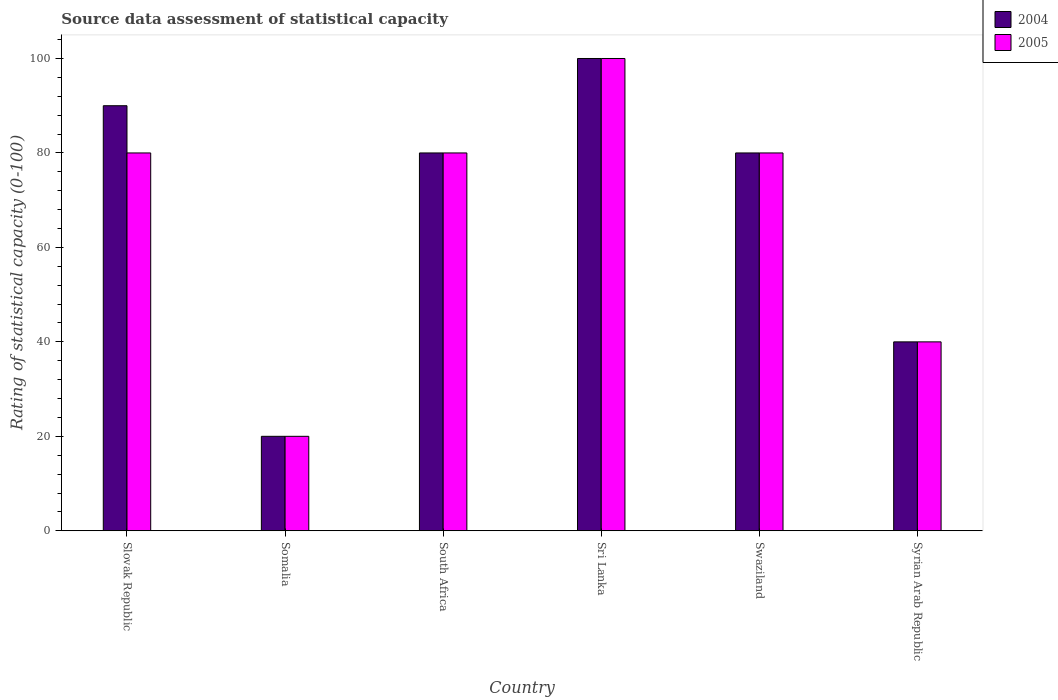How many different coloured bars are there?
Provide a succinct answer. 2. How many groups of bars are there?
Offer a terse response. 6. How many bars are there on the 1st tick from the left?
Provide a succinct answer. 2. What is the label of the 1st group of bars from the left?
Make the answer very short. Slovak Republic. What is the rating of statistical capacity in 2004 in Swaziland?
Offer a terse response. 80. Across all countries, what is the minimum rating of statistical capacity in 2004?
Ensure brevity in your answer.  20. In which country was the rating of statistical capacity in 2005 maximum?
Offer a terse response. Sri Lanka. In which country was the rating of statistical capacity in 2005 minimum?
Ensure brevity in your answer.  Somalia. What is the total rating of statistical capacity in 2004 in the graph?
Your answer should be compact. 410. What is the average rating of statistical capacity in 2004 per country?
Your answer should be very brief. 68.33. In how many countries, is the rating of statistical capacity in 2005 greater than 76?
Offer a terse response. 4. What is the ratio of the rating of statistical capacity in 2005 in Slovak Republic to that in Swaziland?
Keep it short and to the point. 1. Is the difference between the rating of statistical capacity in 2005 in Somalia and Swaziland greater than the difference between the rating of statistical capacity in 2004 in Somalia and Swaziland?
Ensure brevity in your answer.  No. In how many countries, is the rating of statistical capacity in 2005 greater than the average rating of statistical capacity in 2005 taken over all countries?
Offer a terse response. 4. Is the sum of the rating of statistical capacity in 2004 in Swaziland and Syrian Arab Republic greater than the maximum rating of statistical capacity in 2005 across all countries?
Your answer should be very brief. Yes. What does the 2nd bar from the left in Somalia represents?
Give a very brief answer. 2005. What does the 1st bar from the right in Sri Lanka represents?
Offer a terse response. 2005. Are all the bars in the graph horizontal?
Your answer should be compact. No. How many countries are there in the graph?
Ensure brevity in your answer.  6. Does the graph contain any zero values?
Provide a succinct answer. No. Does the graph contain grids?
Provide a succinct answer. No. Where does the legend appear in the graph?
Keep it short and to the point. Top right. How are the legend labels stacked?
Your response must be concise. Vertical. What is the title of the graph?
Ensure brevity in your answer.  Source data assessment of statistical capacity. What is the label or title of the Y-axis?
Your answer should be compact. Rating of statistical capacity (0-100). What is the Rating of statistical capacity (0-100) in 2004 in Slovak Republic?
Your answer should be very brief. 90. What is the Rating of statistical capacity (0-100) in 2004 in Somalia?
Make the answer very short. 20. What is the Rating of statistical capacity (0-100) of 2005 in Somalia?
Your answer should be very brief. 20. What is the Rating of statistical capacity (0-100) in 2004 in Sri Lanka?
Your response must be concise. 100. What is the Rating of statistical capacity (0-100) in 2004 in Swaziland?
Give a very brief answer. 80. What is the Rating of statistical capacity (0-100) in 2004 in Syrian Arab Republic?
Offer a very short reply. 40. What is the Rating of statistical capacity (0-100) in 2005 in Syrian Arab Republic?
Provide a succinct answer. 40. Across all countries, what is the maximum Rating of statistical capacity (0-100) in 2004?
Provide a short and direct response. 100. What is the total Rating of statistical capacity (0-100) of 2004 in the graph?
Make the answer very short. 410. What is the total Rating of statistical capacity (0-100) in 2005 in the graph?
Your answer should be compact. 400. What is the difference between the Rating of statistical capacity (0-100) of 2004 in Slovak Republic and that in South Africa?
Your answer should be compact. 10. What is the difference between the Rating of statistical capacity (0-100) of 2004 in Slovak Republic and that in Sri Lanka?
Keep it short and to the point. -10. What is the difference between the Rating of statistical capacity (0-100) in 2005 in Slovak Republic and that in Sri Lanka?
Keep it short and to the point. -20. What is the difference between the Rating of statistical capacity (0-100) of 2004 in Slovak Republic and that in Swaziland?
Offer a very short reply. 10. What is the difference between the Rating of statistical capacity (0-100) in 2004 in Slovak Republic and that in Syrian Arab Republic?
Provide a succinct answer. 50. What is the difference between the Rating of statistical capacity (0-100) of 2005 in Slovak Republic and that in Syrian Arab Republic?
Make the answer very short. 40. What is the difference between the Rating of statistical capacity (0-100) in 2004 in Somalia and that in South Africa?
Your answer should be very brief. -60. What is the difference between the Rating of statistical capacity (0-100) in 2005 in Somalia and that in South Africa?
Offer a terse response. -60. What is the difference between the Rating of statistical capacity (0-100) of 2004 in Somalia and that in Sri Lanka?
Provide a short and direct response. -80. What is the difference between the Rating of statistical capacity (0-100) in 2005 in Somalia and that in Sri Lanka?
Offer a terse response. -80. What is the difference between the Rating of statistical capacity (0-100) in 2004 in Somalia and that in Swaziland?
Provide a short and direct response. -60. What is the difference between the Rating of statistical capacity (0-100) in 2005 in Somalia and that in Swaziland?
Provide a short and direct response. -60. What is the difference between the Rating of statistical capacity (0-100) of 2004 in Somalia and that in Syrian Arab Republic?
Give a very brief answer. -20. What is the difference between the Rating of statistical capacity (0-100) in 2005 in Somalia and that in Syrian Arab Republic?
Offer a terse response. -20. What is the difference between the Rating of statistical capacity (0-100) of 2005 in South Africa and that in Swaziland?
Keep it short and to the point. 0. What is the difference between the Rating of statistical capacity (0-100) of 2004 in Sri Lanka and that in Swaziland?
Your response must be concise. 20. What is the difference between the Rating of statistical capacity (0-100) of 2005 in Sri Lanka and that in Syrian Arab Republic?
Provide a short and direct response. 60. What is the difference between the Rating of statistical capacity (0-100) of 2004 in Swaziland and that in Syrian Arab Republic?
Keep it short and to the point. 40. What is the difference between the Rating of statistical capacity (0-100) of 2004 in Slovak Republic and the Rating of statistical capacity (0-100) of 2005 in Somalia?
Ensure brevity in your answer.  70. What is the difference between the Rating of statistical capacity (0-100) in 2004 in Slovak Republic and the Rating of statistical capacity (0-100) in 2005 in South Africa?
Make the answer very short. 10. What is the difference between the Rating of statistical capacity (0-100) in 2004 in Slovak Republic and the Rating of statistical capacity (0-100) in 2005 in Sri Lanka?
Give a very brief answer. -10. What is the difference between the Rating of statistical capacity (0-100) of 2004 in Slovak Republic and the Rating of statistical capacity (0-100) of 2005 in Swaziland?
Offer a terse response. 10. What is the difference between the Rating of statistical capacity (0-100) of 2004 in Somalia and the Rating of statistical capacity (0-100) of 2005 in South Africa?
Your answer should be very brief. -60. What is the difference between the Rating of statistical capacity (0-100) of 2004 in Somalia and the Rating of statistical capacity (0-100) of 2005 in Sri Lanka?
Make the answer very short. -80. What is the difference between the Rating of statistical capacity (0-100) of 2004 in Somalia and the Rating of statistical capacity (0-100) of 2005 in Swaziland?
Make the answer very short. -60. What is the difference between the Rating of statistical capacity (0-100) of 2004 in South Africa and the Rating of statistical capacity (0-100) of 2005 in Sri Lanka?
Provide a short and direct response. -20. What is the difference between the Rating of statistical capacity (0-100) of 2004 in South Africa and the Rating of statistical capacity (0-100) of 2005 in Swaziland?
Provide a short and direct response. 0. What is the difference between the Rating of statistical capacity (0-100) in 2004 in Sri Lanka and the Rating of statistical capacity (0-100) in 2005 in Syrian Arab Republic?
Your answer should be compact. 60. What is the average Rating of statistical capacity (0-100) in 2004 per country?
Your response must be concise. 68.33. What is the average Rating of statistical capacity (0-100) in 2005 per country?
Offer a terse response. 66.67. What is the difference between the Rating of statistical capacity (0-100) in 2004 and Rating of statistical capacity (0-100) in 2005 in Somalia?
Keep it short and to the point. 0. What is the difference between the Rating of statistical capacity (0-100) of 2004 and Rating of statistical capacity (0-100) of 2005 in South Africa?
Give a very brief answer. 0. What is the difference between the Rating of statistical capacity (0-100) in 2004 and Rating of statistical capacity (0-100) in 2005 in Sri Lanka?
Ensure brevity in your answer.  0. What is the ratio of the Rating of statistical capacity (0-100) in 2004 in Slovak Republic to that in South Africa?
Your answer should be compact. 1.12. What is the ratio of the Rating of statistical capacity (0-100) in 2005 in Slovak Republic to that in Sri Lanka?
Provide a succinct answer. 0.8. What is the ratio of the Rating of statistical capacity (0-100) in 2004 in Slovak Republic to that in Swaziland?
Ensure brevity in your answer.  1.12. What is the ratio of the Rating of statistical capacity (0-100) of 2004 in Slovak Republic to that in Syrian Arab Republic?
Offer a very short reply. 2.25. What is the ratio of the Rating of statistical capacity (0-100) of 2005 in Slovak Republic to that in Syrian Arab Republic?
Offer a very short reply. 2. What is the ratio of the Rating of statistical capacity (0-100) in 2005 in Somalia to that in South Africa?
Your response must be concise. 0.25. What is the ratio of the Rating of statistical capacity (0-100) of 2004 in Somalia to that in Sri Lanka?
Your answer should be very brief. 0.2. What is the ratio of the Rating of statistical capacity (0-100) of 2005 in Somalia to that in Swaziland?
Provide a short and direct response. 0.25. What is the ratio of the Rating of statistical capacity (0-100) in 2004 in South Africa to that in Sri Lanka?
Give a very brief answer. 0.8. What is the ratio of the Rating of statistical capacity (0-100) in 2004 in South Africa to that in Swaziland?
Offer a terse response. 1. What is the ratio of the Rating of statistical capacity (0-100) in 2004 in South Africa to that in Syrian Arab Republic?
Keep it short and to the point. 2. What is the ratio of the Rating of statistical capacity (0-100) in 2004 in Sri Lanka to that in Swaziland?
Keep it short and to the point. 1.25. What is the ratio of the Rating of statistical capacity (0-100) in 2004 in Swaziland to that in Syrian Arab Republic?
Your answer should be very brief. 2. What is the ratio of the Rating of statistical capacity (0-100) of 2005 in Swaziland to that in Syrian Arab Republic?
Make the answer very short. 2. What is the difference between the highest and the second highest Rating of statistical capacity (0-100) in 2004?
Your answer should be very brief. 10. What is the difference between the highest and the second highest Rating of statistical capacity (0-100) in 2005?
Your answer should be very brief. 20. What is the difference between the highest and the lowest Rating of statistical capacity (0-100) in 2004?
Ensure brevity in your answer.  80. What is the difference between the highest and the lowest Rating of statistical capacity (0-100) in 2005?
Offer a terse response. 80. 